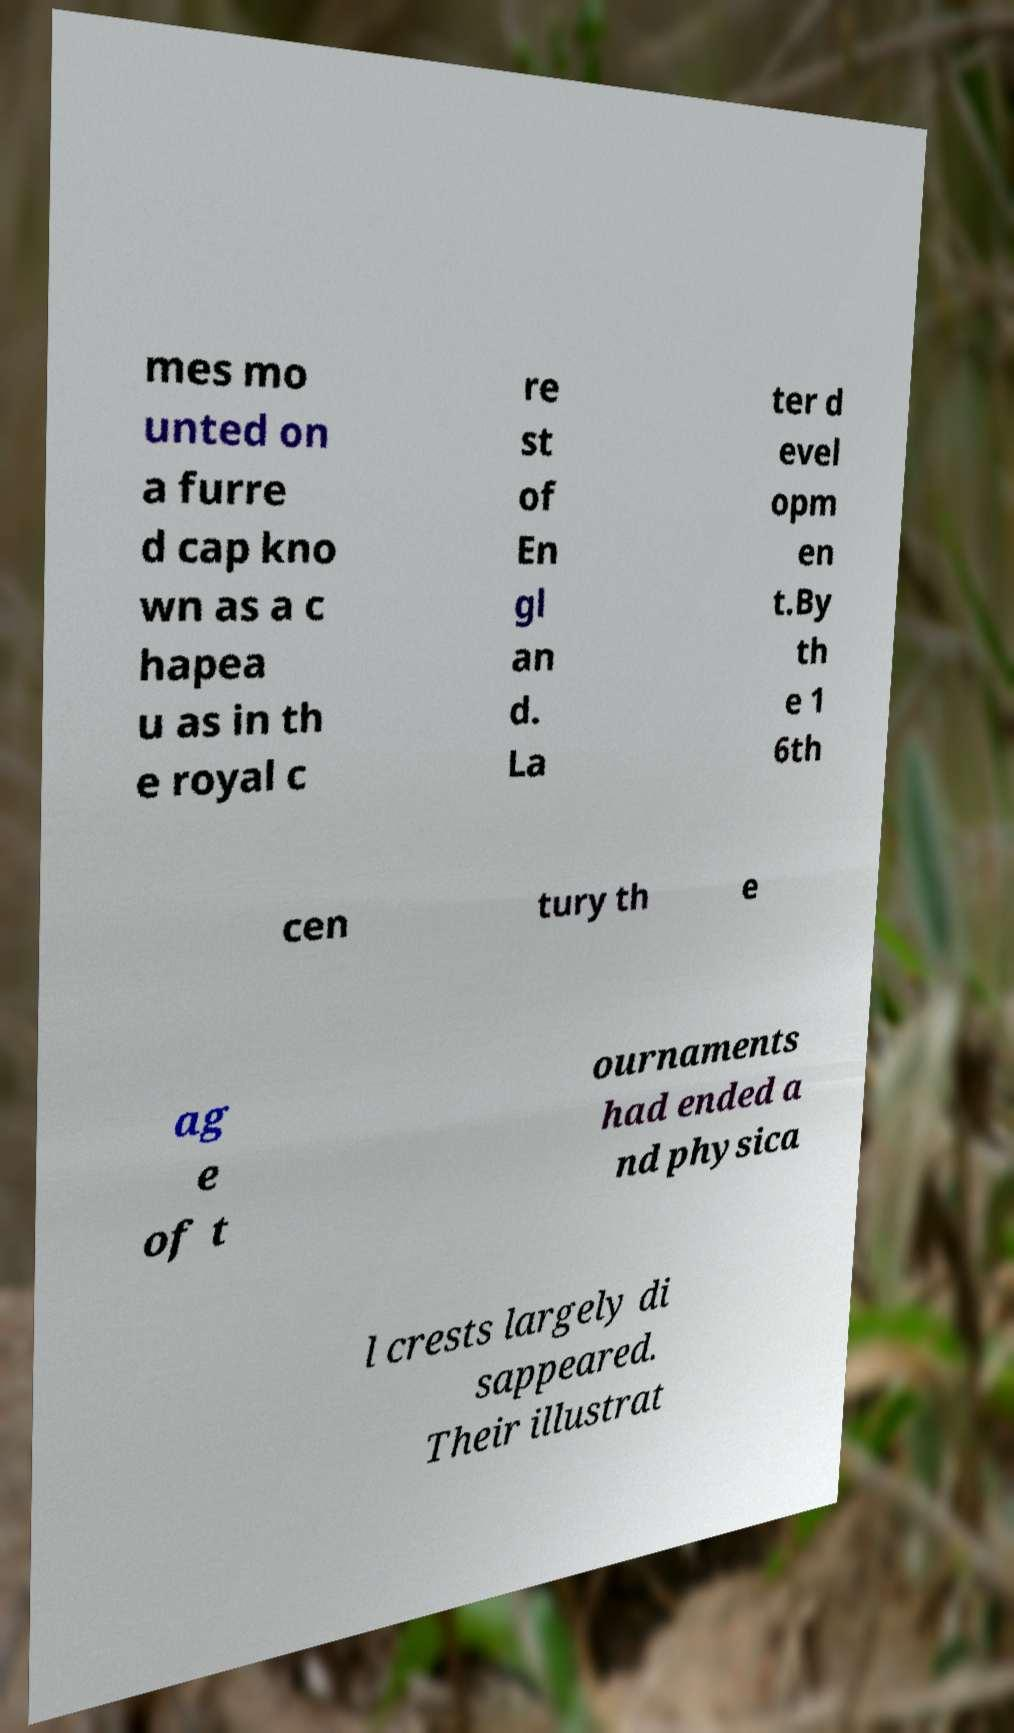For documentation purposes, I need the text within this image transcribed. Could you provide that? mes mo unted on a furre d cap kno wn as a c hapea u as in th e royal c re st of En gl an d. La ter d evel opm en t.By th e 1 6th cen tury th e ag e of t ournaments had ended a nd physica l crests largely di sappeared. Their illustrat 